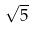<formula> <loc_0><loc_0><loc_500><loc_500>\sqrt { 5 }</formula> 